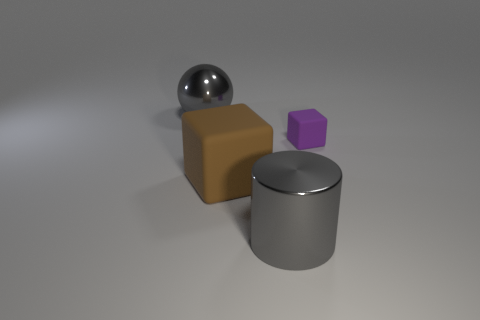What material is the block that is left of the gray metallic thing in front of the tiny purple block?
Offer a very short reply. Rubber. Is the gray ball the same size as the purple matte block?
Give a very brief answer. No. How many objects are either small brown cylinders or gray spheres?
Ensure brevity in your answer.  1. What is the size of the thing that is both on the right side of the brown rubber object and behind the shiny cylinder?
Provide a short and direct response. Small. Is the number of brown rubber objects that are on the left side of the large rubber thing less than the number of brown matte cubes?
Your answer should be very brief. Yes. What is the shape of the gray object that is the same material as the sphere?
Provide a succinct answer. Cylinder. Does the metallic thing that is to the left of the gray shiny cylinder have the same shape as the big metal object that is in front of the purple rubber cube?
Give a very brief answer. No. Is the number of blocks that are in front of the big metal cylinder less than the number of things that are in front of the gray metallic sphere?
Your answer should be compact. Yes. The large thing that is the same color as the big sphere is what shape?
Give a very brief answer. Cylinder. What number of gray metallic things are the same size as the brown matte object?
Offer a very short reply. 2. 